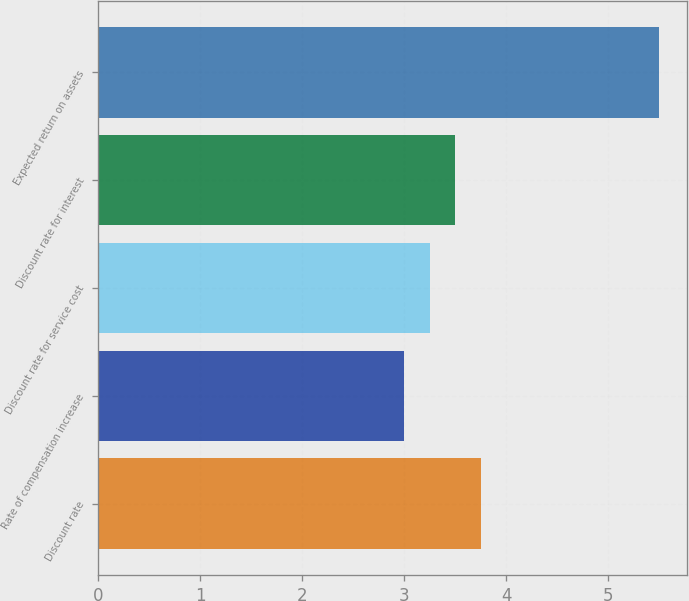Convert chart to OTSL. <chart><loc_0><loc_0><loc_500><loc_500><bar_chart><fcel>Discount rate<fcel>Rate of compensation increase<fcel>Discount rate for service cost<fcel>Discount rate for interest<fcel>Expected return on assets<nl><fcel>3.75<fcel>3<fcel>3.25<fcel>3.5<fcel>5.5<nl></chart> 